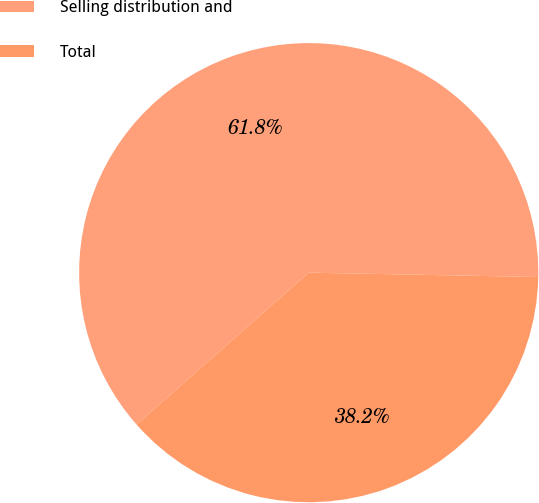<chart> <loc_0><loc_0><loc_500><loc_500><pie_chart><fcel>Selling distribution and<fcel>Total<nl><fcel>61.81%<fcel>38.19%<nl></chart> 